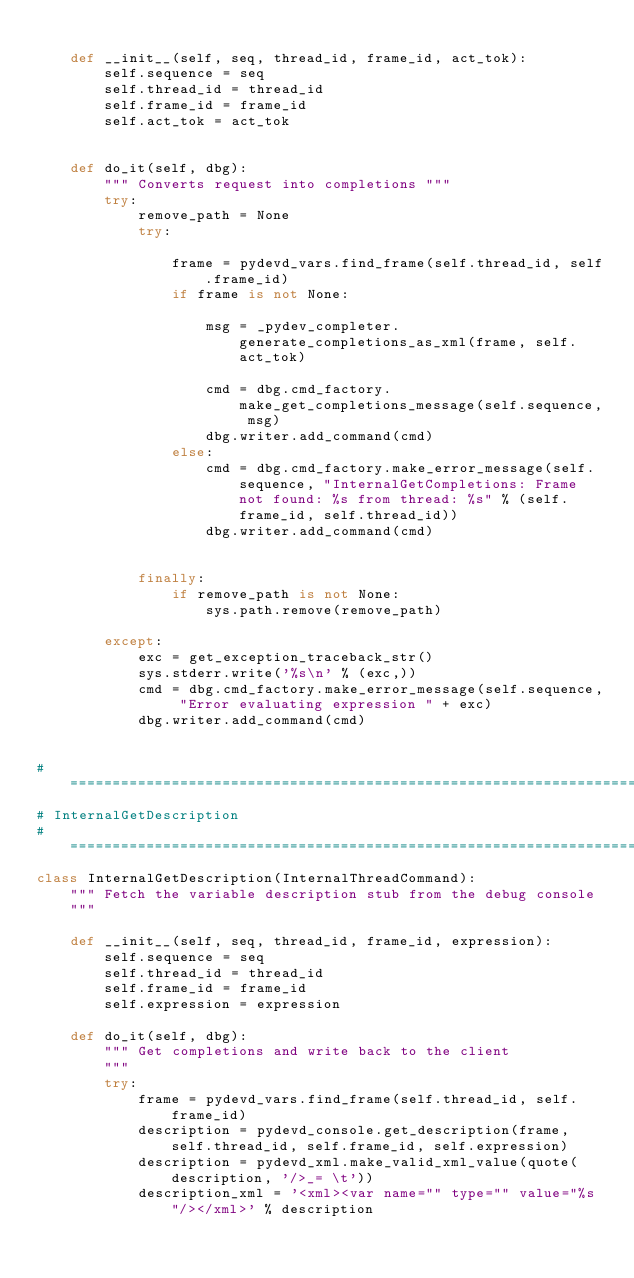Convert code to text. <code><loc_0><loc_0><loc_500><loc_500><_Python_>
    def __init__(self, seq, thread_id, frame_id, act_tok):
        self.sequence = seq
        self.thread_id = thread_id
        self.frame_id = frame_id
        self.act_tok = act_tok


    def do_it(self, dbg):
        """ Converts request into completions """
        try:
            remove_path = None
            try:

                frame = pydevd_vars.find_frame(self.thread_id, self.frame_id)
                if frame is not None:

                    msg = _pydev_completer.generate_completions_as_xml(frame, self.act_tok)

                    cmd = dbg.cmd_factory.make_get_completions_message(self.sequence, msg)
                    dbg.writer.add_command(cmd)
                else:
                    cmd = dbg.cmd_factory.make_error_message(self.sequence, "InternalGetCompletions: Frame not found: %s from thread: %s" % (self.frame_id, self.thread_id))
                    dbg.writer.add_command(cmd)


            finally:
                if remove_path is not None:
                    sys.path.remove(remove_path)

        except:
            exc = get_exception_traceback_str()
            sys.stderr.write('%s\n' % (exc,))
            cmd = dbg.cmd_factory.make_error_message(self.sequence, "Error evaluating expression " + exc)
            dbg.writer.add_command(cmd)


# =======================================================================================================================
# InternalGetDescription
# =======================================================================================================================
class InternalGetDescription(InternalThreadCommand):
    """ Fetch the variable description stub from the debug console
    """

    def __init__(self, seq, thread_id, frame_id, expression):
        self.sequence = seq
        self.thread_id = thread_id
        self.frame_id = frame_id
        self.expression = expression

    def do_it(self, dbg):
        """ Get completions and write back to the client
        """
        try:
            frame = pydevd_vars.find_frame(self.thread_id, self.frame_id)
            description = pydevd_console.get_description(frame, self.thread_id, self.frame_id, self.expression)
            description = pydevd_xml.make_valid_xml_value(quote(description, '/>_= \t'))
            description_xml = '<xml><var name="" type="" value="%s"/></xml>' % description</code> 